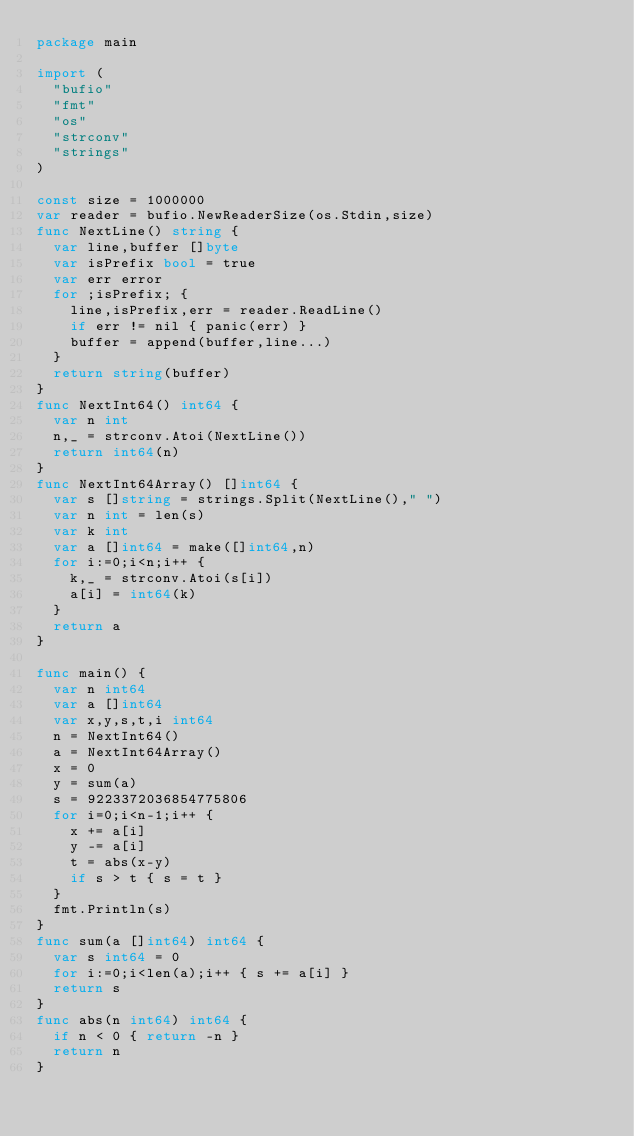Convert code to text. <code><loc_0><loc_0><loc_500><loc_500><_Go_>package main

import (
  "bufio"
  "fmt"
  "os"
  "strconv"
  "strings"
)

const size = 1000000
var reader = bufio.NewReaderSize(os.Stdin,size)
func NextLine() string {
  var line,buffer []byte
  var isPrefix bool = true
  var err error
  for ;isPrefix; {
    line,isPrefix,err = reader.ReadLine()
    if err != nil { panic(err) }
    buffer = append(buffer,line...)
  }
  return string(buffer)
}
func NextInt64() int64 {
  var n int
  n,_ = strconv.Atoi(NextLine())
  return int64(n)
}
func NextInt64Array() []int64 {
  var s []string = strings.Split(NextLine()," ")
  var n int = len(s)
  var k int
  var a []int64 = make([]int64,n)
  for i:=0;i<n;i++ {
    k,_ = strconv.Atoi(s[i])
    a[i] = int64(k)
  }
  return a
}

func main() {
  var n int64
  var a []int64
  var x,y,s,t,i int64
  n = NextInt64()
  a = NextInt64Array()
  x = 0
  y = sum(a)
  s = 9223372036854775806
  for i=0;i<n-1;i++ {
    x += a[i]
    y -= a[i]
    t = abs(x-y)
    if s > t { s = t }
  }
  fmt.Println(s)
}
func sum(a []int64) int64 {
  var s int64 = 0
  for i:=0;i<len(a);i++ { s += a[i] }
  return s
}
func abs(n int64) int64 {
  if n < 0 { return -n }
  return n
}</code> 